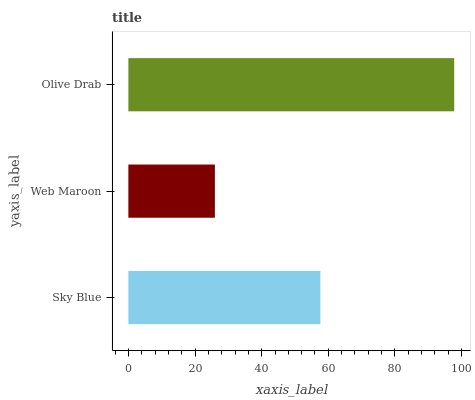Is Web Maroon the minimum?
Answer yes or no. Yes. Is Olive Drab the maximum?
Answer yes or no. Yes. Is Olive Drab the minimum?
Answer yes or no. No. Is Web Maroon the maximum?
Answer yes or no. No. Is Olive Drab greater than Web Maroon?
Answer yes or no. Yes. Is Web Maroon less than Olive Drab?
Answer yes or no. Yes. Is Web Maroon greater than Olive Drab?
Answer yes or no. No. Is Olive Drab less than Web Maroon?
Answer yes or no. No. Is Sky Blue the high median?
Answer yes or no. Yes. Is Sky Blue the low median?
Answer yes or no. Yes. Is Web Maroon the high median?
Answer yes or no. No. Is Olive Drab the low median?
Answer yes or no. No. 